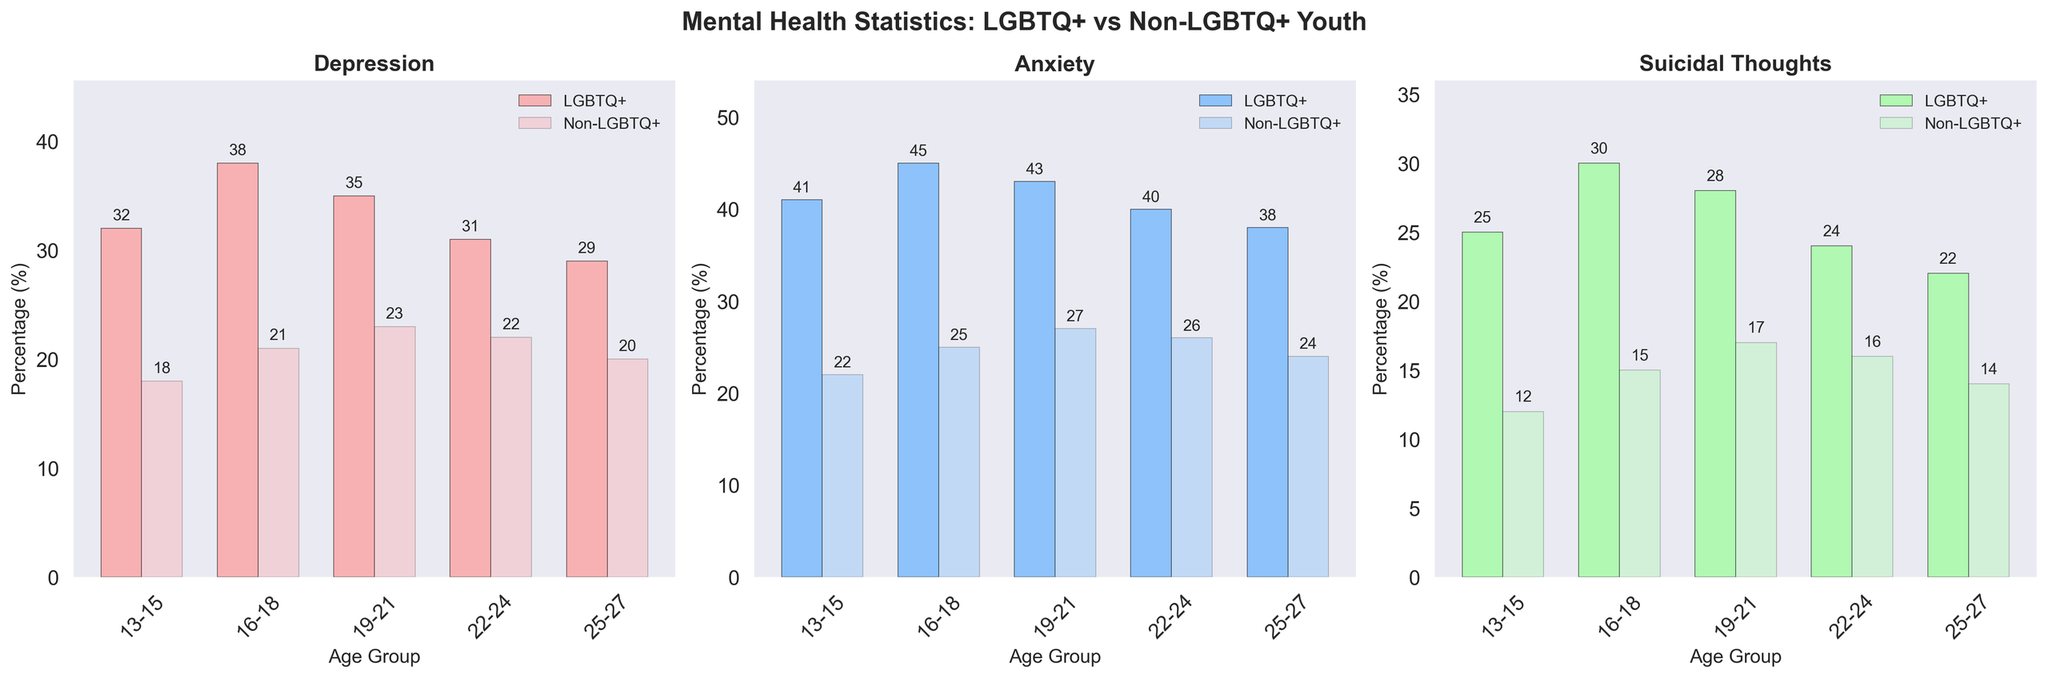What's the title of the figure? The title of the figure is written at the top and is usually the most prominent text.
Answer: Mental Health Statistics: LGBTQ+ vs Non-LGBTQ+ Youth How many age groups are represented in each subplot? The x-axis of each subplot shows the categories, which are the same for each subplot. Simply count the number of age groups listed along the x-axis. There are five age groups: 13-15, 16-18, 19-21, 22-24, and 25-27.
Answer: 5 Which age group has the highest reported percentage of anxiety among LGBTQ+ youth? Look for the tallest bar in the 'Anxiety' subplot with the color representing LGBTQ+ youth and check its corresponding age group on the x-axis.
Answer: 16-18 By how much does the percentage of depression among LGBTQ+ youth aged 16-18 exceed that of non-LGBTQ+ youth of the same age? Find the height of the bars representing the 16-18 age group for both LGBTQ+ and non-LGBTQ+ youth in the 'Depression' subplot, then subtract the non-LGBTQ+ value from the LGBTQ+ value: 38 - 21.
Answer: 17 What is the average percentage of suicidal thoughts among LGBTQ+ youth across all age groups? Add the percentages of suicidal thoughts among LGBTQ+ youth for all age groups and divide the sum by the number of age groups: (25 + 30 + 28 + 24 + 22)/5.
Answer: 25.8 Which age group shows the least difference in anxiety levels between LGBTQ+ and non-LGBTQ+ youth? Calculate the difference in anxiety percentages for each age group and identify the smallest difference. Differences: 19, 20, 16, 14, 14. The smallest difference is for age groups 22-24 and 25-27.
Answer: 22-24, 25-27 (tie) In which subplot is the percentage difference between LGBTQ+ and non-LGBTQ+ youth the most consistent across age groups? Consider the consistency of the difference in each subplot (Depression, Anxiety, Suicidal Thoughts) by comparing the variation. Anxiety shows relatively consistent differences across all age groups.
Answer: Anxiety What is the trend of suicidal thoughts among non-LGBTQ+ youth as age increases? Observe the 'Suicidal Thoughts' subplot and note the changes in height of the bars representing non-LGBTQ+ youth as they progress from younger to older age groups.
Answer: Increasing How does the percentage of depression among LGBTQ+ youth aged 19-21 compare to the percentage of anxiety in the same age group? Locate the bars corresponding to the 19-21 age group in both the 'Depression' and 'Anxiety' subplots, then compare their heights.
Answer: Anxiety is higher (43) than depression (35) Which condition shows the most significant difference in prevalence between LGBTQ+ and non-LGBTQ+ youth for the 13-15 age group? For the 13-15 age group, check the differences in heights of the bars in each subplot. The differences are as follows: Depression (14), Anxiety (19), Suicidal Thoughts (13). The largest difference is in Anxiety.
Answer: Anxiety 